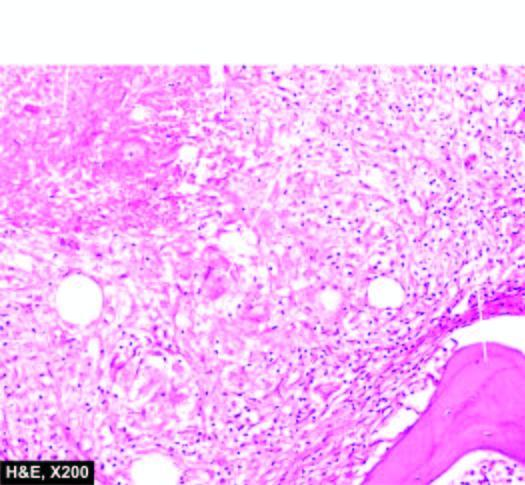what are there with minute areas of caseation necrosis and surrounded by langhans ' giant cells?
Answer the question using a single word or phrase. Epithelioid cell granulomas 